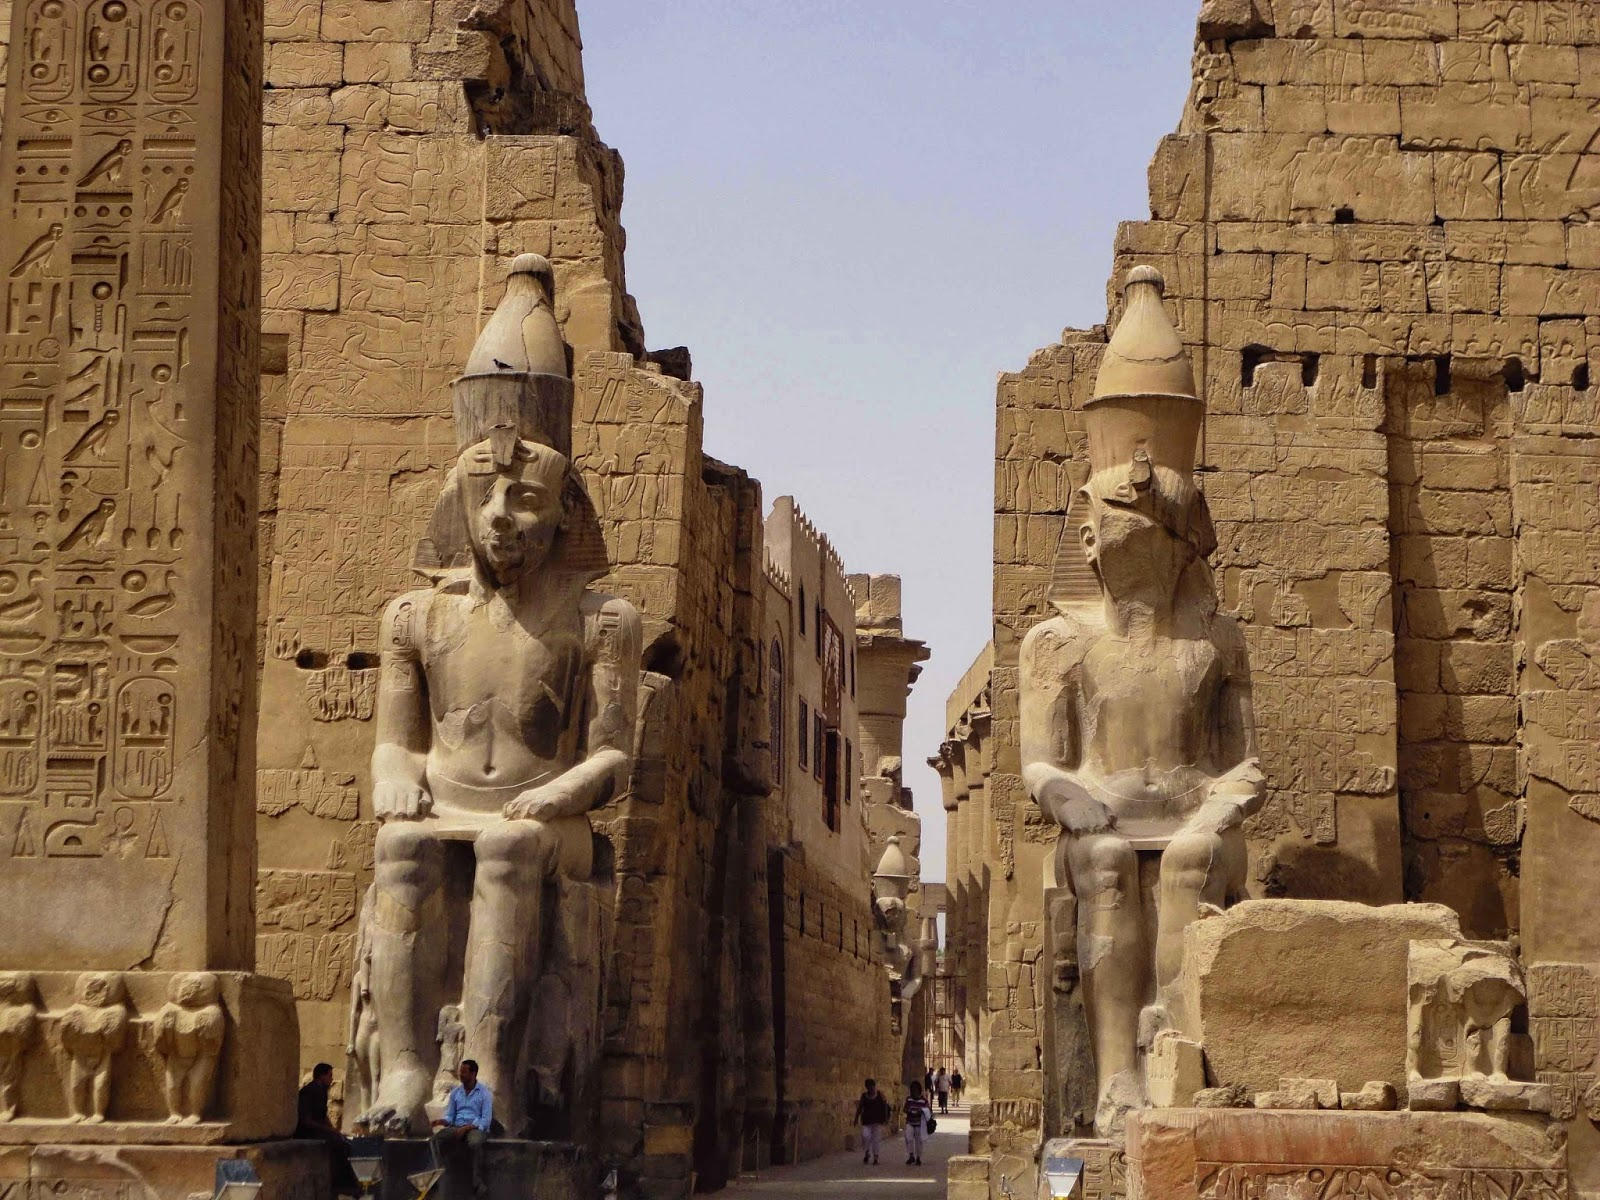What would a quick tour look like here? A quick tour of the Luxor Temple would start at the grand entrance, flanked by towering statues of Ramses II. Moving through the massive pylons, you'd walk down the central avenue, lined with additional statues and richly inscribed walls. Pausing briefly to admire the intricate hieroglyphics, you'd continue to the inner sanctum where the sacred Barque Shrine stands. The tour would provide a snapshot of the temple's architectural brilliance while giving a glimpse into the rich history and spiritual significance of this ancient site. 